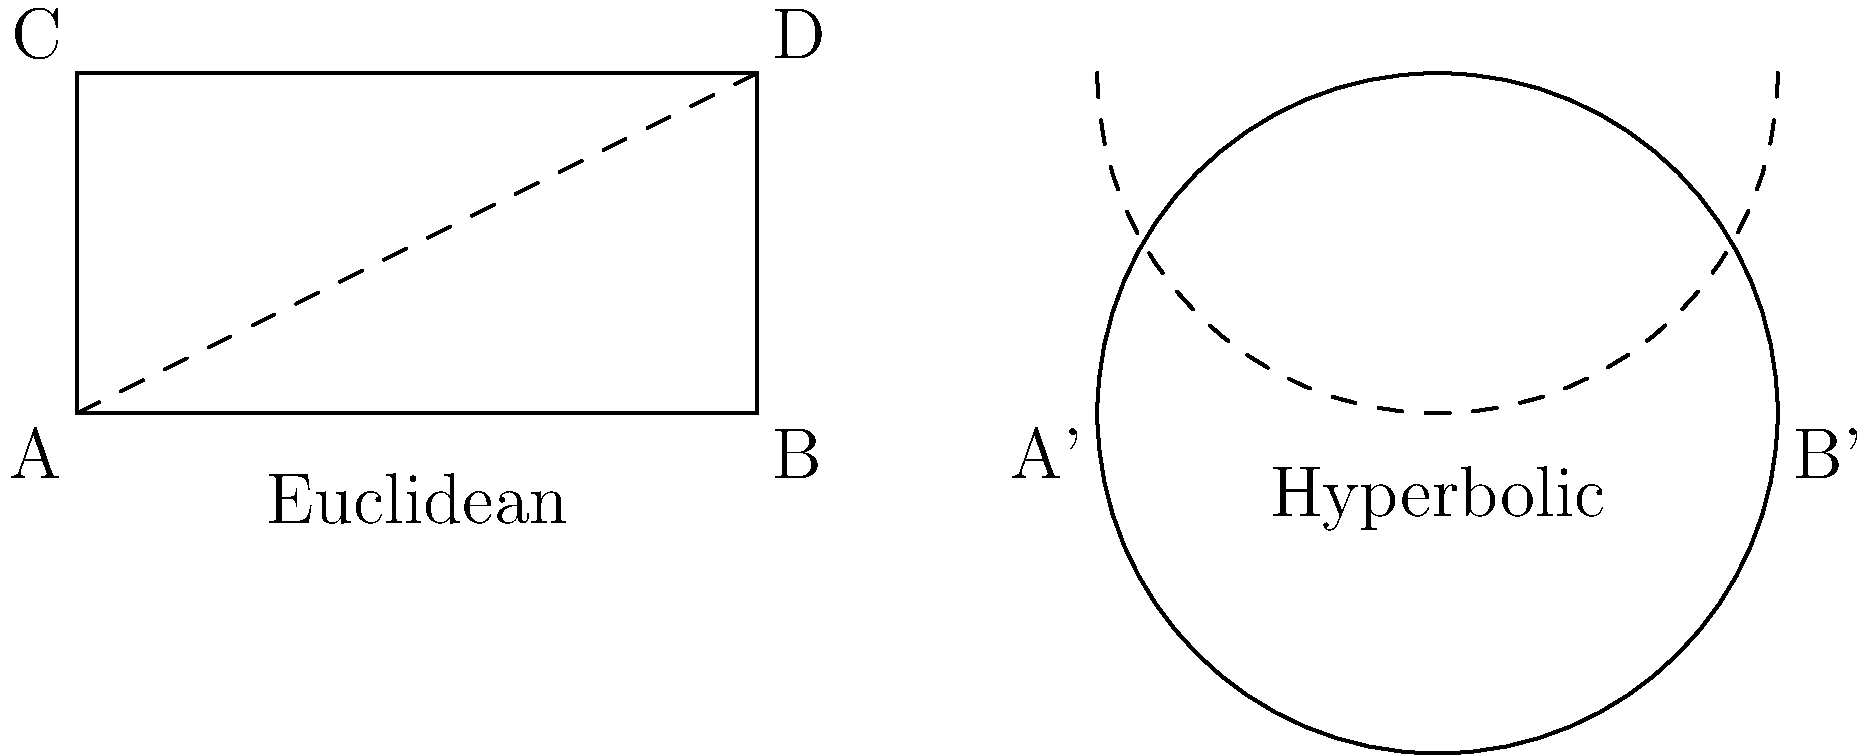In your ethnographic studies of different cultures, you've encountered various mathematical concepts. Consider the parallel postulate in Euclidean and hyperbolic geometry as shown in the diagram. In Euclidean geometry, line CD is parallel to AB. In hyperbolic geometry (represented by the Poincaré disk model), the curved line is "parallel" to A'B'. What is the key difference between these two types of parallel lines, and how might this concept influence the way different cultures perceive space? To answer this question, let's break down the key differences between parallel lines in Euclidean and hyperbolic geometry:

1. Euclidean geometry:
   - Parallel lines maintain a constant distance from each other.
   - In the diagram, CD and AB are straight lines that never intersect.
   - Only one line parallel to AB can be drawn through point C.

2. Hyperbolic geometry:
   - "Parallel" lines in hyperbolic space diverge from each other.
   - In the Poincaré disk model, straight lines are represented by arcs perpendicular to the boundary circle.
   - The curved line in the hyperbolic plane diverges from A'B'.
   - Infinitely many "parallel" lines can be drawn through a point not on the given line.

3. Key difference:
   - In Euclidean geometry, parallel lines maintain a constant distance.
   - In hyperbolic geometry, "parallel" lines diverge and the distance between them increases.

4. Cultural implications:
   - Cultures based on Euclidean concepts might perceive space as more "orderly" and predictable.
   - Cultures familiar with hyperbolic concepts might have a more fluid understanding of space and distance.
   - This could influence architecture, art, navigation, and spatial reasoning in different societies.

The key difference is that Euclidean parallel lines maintain a constant distance, while hyperbolic "parallel" lines diverge. This fundamental geometric distinction could lead to varying perceptions of space across cultures, potentially influencing their worldviews and practices.
Answer: Euclidean parallels maintain constant distance; hyperbolic parallels diverge. This may influence cultural perceptions of space and distance. 